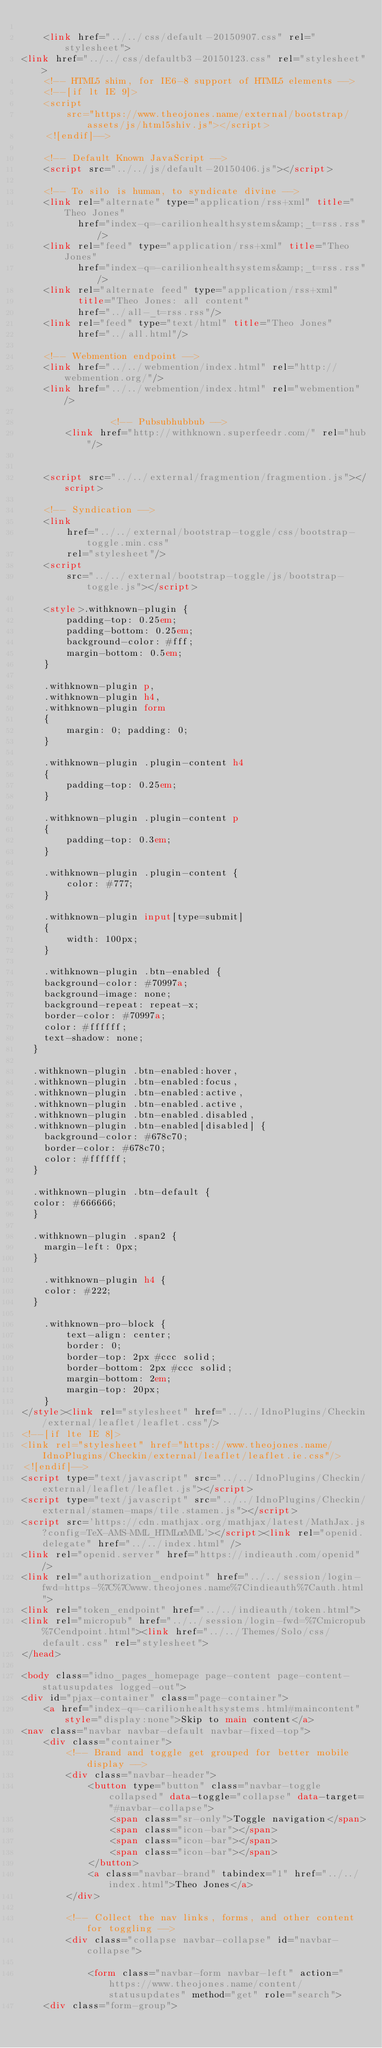Convert code to text. <code><loc_0><loc_0><loc_500><loc_500><_HTML_>
    <link href="../../css/default-20150907.css" rel="stylesheet">
<link href="../../css/defaultb3-20150123.css" rel="stylesheet">
    <!-- HTML5 shim, for IE6-8 support of HTML5 elements -->
    <!--[if lt IE 9]>
    <script
        src="https://www.theojones.name/external/bootstrap/assets/js/html5shiv.js"></script>
    <![endif]-->

    <!-- Default Known JavaScript -->
    <script src="../../js/default-20150406.js"></script>

    <!-- To silo is human, to syndicate divine -->
    <link rel="alternate" type="application/rss+xml" title="Theo Jones"
          href="index-q=-carilionhealthsystems&amp;_t=rss.rss"/>
    <link rel="feed" type="application/rss+xml" title="Theo Jones"
          href="index-q=-carilionhealthsystems&amp;_t=rss.rss"/>
    <link rel="alternate feed" type="application/rss+xml"
          title="Theo Jones: all content"
          href="../all-_t=rss.rss"/>
    <link rel="feed" type="text/html" title="Theo Jones"
          href="../all.html"/>

    <!-- Webmention endpoint -->
    <link href="../../webmention/index.html" rel="http://webmention.org/"/>
    <link href="../../webmention/index.html" rel="webmention"/>

                <!-- Pubsubhubbub -->
        <link href="http://withknown.superfeedr.com/" rel="hub"/>
    
    
    <script src="../../external/fragmention/fragmention.js"></script>

    <!-- Syndication -->
    <link
        href="../../external/bootstrap-toggle/css/bootstrap-toggle.min.css"
        rel="stylesheet"/>
    <script
        src="../../external/bootstrap-toggle/js/bootstrap-toggle.js"></script>

    <style>.withknown-plugin {
        padding-top: 0.25em;
        padding-bottom: 0.25em;
        background-color: #fff;
        margin-bottom: 0.5em;
    }

    .withknown-plugin p,
    .withknown-plugin h4,
    .withknown-plugin form
    {
        margin: 0; padding: 0;
    }

    .withknown-plugin .plugin-content h4
    {
        padding-top: 0.25em;
    }

    .withknown-plugin .plugin-content p
    {
        padding-top: 0.3em;
    }

    .withknown-plugin .plugin-content {
        color: #777;
    }

    .withknown-plugin input[type=submit]
    {
        width: 100px;
    }
    
    .withknown-plugin .btn-enabled {
    background-color: #70997a;
    background-image: none;
    background-repeat: repeat-x;
    border-color: #70997a;
    color: #ffffff;
    text-shadow: none;
	}
	
	.withknown-plugin .btn-enabled:hover, 
	.withknown-plugin .btn-enabled:focus, 
	.withknown-plugin .btn-enabled:active, 
	.withknown-plugin .btn-enabled.active, 
	.withknown-plugin .btn-enabled.disabled, 
	.withknown-plugin .btn-enabled[disabled] {
    background-color: #678c70;
    border-color: #678c70;
    color: #ffffff;
	}
	
	.withknown-plugin .btn-default {
	color: #666666;
	}
	
	.withknown-plugin .span2 {
		margin-left: 0px;
	}
	
    .withknown-plugin h4 {
		color: #222;
	}

    .withknown-pro-block {
        text-align: center;
        border: 0;
        border-top: 2px #ccc solid;
        border-bottom: 2px #ccc solid;
        margin-bottom: 2em;
        margin-top: 20px;
    }
</style><link rel="stylesheet" href="../../IdnoPlugins/Checkin/external/leaflet/leaflet.css"/>
<!--[if lte IE 8]>
<link rel="stylesheet" href="https://www.theojones.name/IdnoPlugins/Checkin/external/leaflet/leaflet.ie.css"/>
<![endif]-->
<script type="text/javascript" src="../../IdnoPlugins/Checkin/external/leaflet/leaflet.js"></script>
<script type="text/javascript" src="../../IdnoPlugins/Checkin/external/stamen-maps/tile.stamen.js"></script>
<script src='https://cdn.mathjax.org/mathjax/latest/MathJax.js?config=TeX-AMS-MML_HTMLorMML'></script><link rel="openid.delegate" href="../../index.html" />
<link rel="openid.server" href="https://indieauth.com/openid" />
<link rel="authorization_endpoint" href="../../session/login-fwd=https-%7C%7Cwww.theojones.name%7Cindieauth%7Cauth.html">
<link rel="token_endpoint" href="../../indieauth/token.html">
<link rel="micropub" href="../../session/login-fwd=%7Cmicropub%7Cendpoint.html"><link href="../../Themes/Solo/css/default.css" rel="stylesheet">    
</head>

<body class="idno_pages_homepage page-content page-content-statusupdates logged-out">
<div id="pjax-container" class="page-container">
    <a href="index-q=-carilionhealthsystems.html#maincontent" style="display:none">Skip to main content</a>
<nav class="navbar navbar-default navbar-fixed-top">
    <div class="container">
        <!-- Brand and toggle get grouped for better mobile display -->
        <div class="navbar-header">
            <button type="button" class="navbar-toggle collapsed" data-toggle="collapse" data-target="#navbar-collapse">
                <span class="sr-only">Toggle navigation</span>
                <span class="icon-bar"></span>
                <span class="icon-bar"></span>
                <span class="icon-bar"></span>
            </button>
            <a class="navbar-brand" tabindex="1" href="../../index.html">Theo Jones</a>
        </div>

        <!-- Collect the nav links, forms, and other content for toggling -->
        <div class="collapse navbar-collapse" id="navbar-collapse">

            <form class="navbar-form navbar-left" action="https://www.theojones.name/content/statusupdates" method="get" role="search">
    <div class="form-group"></code> 